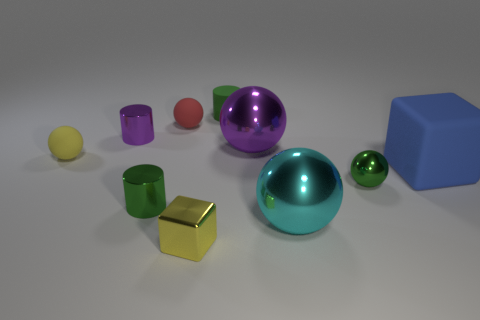How many objects are there in the image? There are ten objects visible in the image: three spheres, one cube, and six cylinders of various sizes and colors.  Can you describe the texture of the objects? Certainly! The objects exhibit two distinct textures: some have a matte finish which diffuses light and gives a soft appearance, like the lilac cylinder and the yellow sphere. Others are glossy, with a reflective surface that mirrors their surroundings, like the teal and purple spheres and the golden cube. 